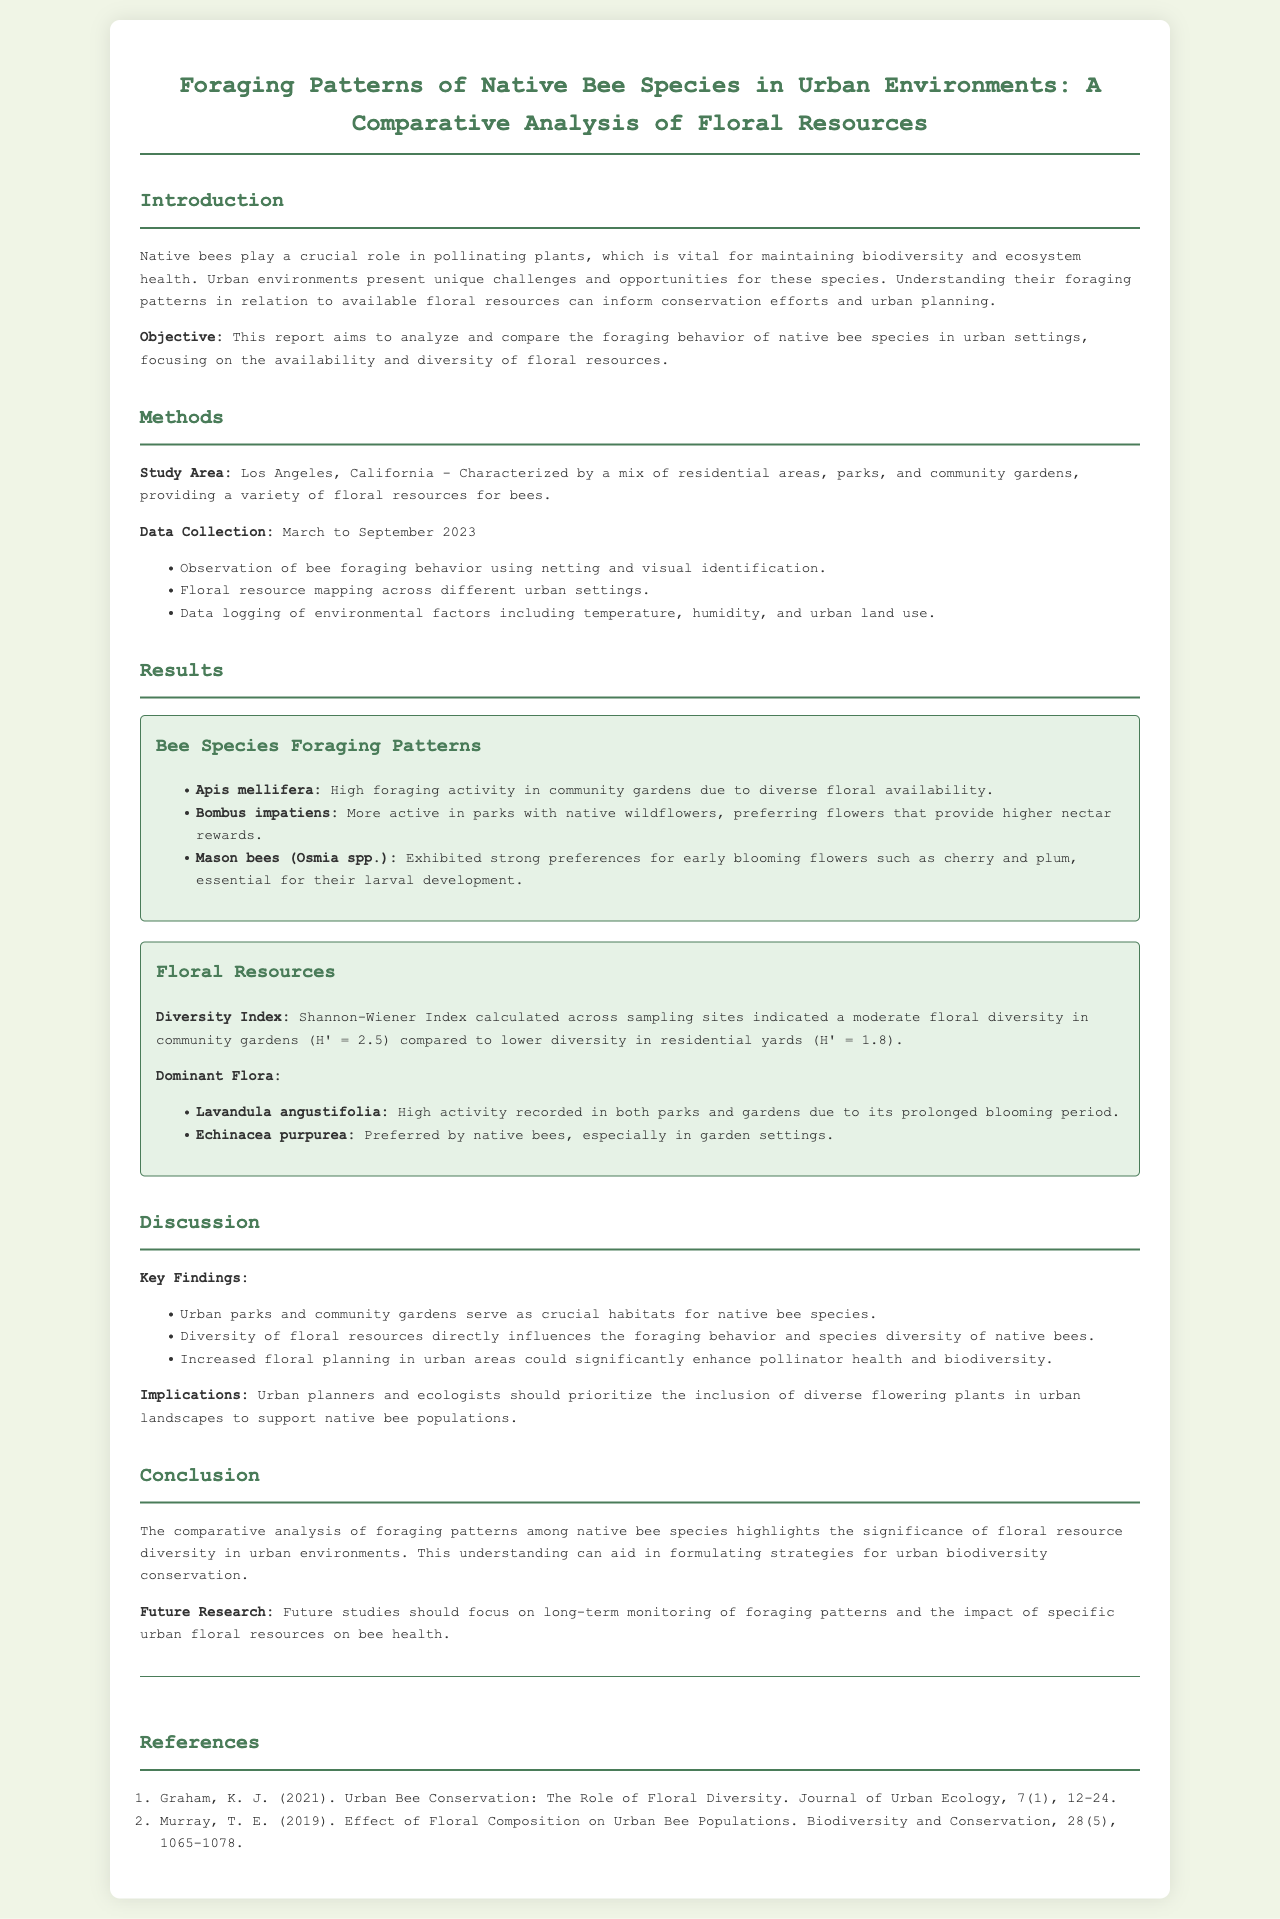What is the study area for the research? The study area is defined as Los Angeles, California, which comprises various urban elements like residential areas, parks, and community gardens.
Answer: Los Angeles, California What months did the data collection occur? The data collection period is specified as occurring from March to September 2023.
Answer: March to September 2023 Which bee species showed high foraging activity in community gardens? The document states that Apis mellifera exhibited high foraging activity in community gardens due to diverse floral availability.
Answer: Apis mellifera What is the Diversity Index value for community gardens? The Shannon-Wiener Index value for community gardens is provided in the document as H' = 2.5.
Answer: H' = 2.5 Which floral resource was preferred by native bees in garden settings? The report mentions Echinacea purpurea as being preferred by native bees, particularly in garden settings.
Answer: Echinacea purpurea What key finding relates to urban parks and community gardens? The document highlights that urban parks and community gardens serve as crucial habitats for native bee species as a key finding.
Answer: Crucial habitats Why is floral resource diversity important? The document explains that the diversity of floral resources directly influences the foraging behavior and species diversity of native bees.
Answer: Directly influences foraging behavior What is suggested for urban planners in terms of floral planting? The report suggests that urban planners should prioritize the inclusion of diverse flowering plants in urban landscapes to support native bee populations.
Answer: Inclusion of diverse flowering plants What is a future research suggestion mentioned in the report? The report suggests that future studies should focus on long-term monitoring of foraging patterns and the impact of specific urban floral resources on bee health.
Answer: Long-term monitoring What is the significance of understanding bee foraging patterns? The document concludes that understanding bee foraging patterns aids in formulating strategies for urban biodiversity conservation.
Answer: Urban biodiversity conservation 